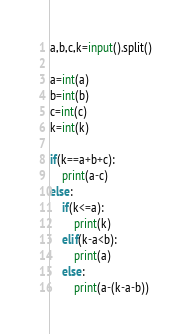Convert code to text. <code><loc_0><loc_0><loc_500><loc_500><_Python_>a,b,c,k=input().split()

a=int(a)
b=int(b)
c=int(c)
k=int(k)

if(k==a+b+c):
    print(a-c)
else:
    if(k<=a):
        print(k)
    elif(k-a<b):
        print(a)
    else:
        print(a-(k-a-b))
</code> 